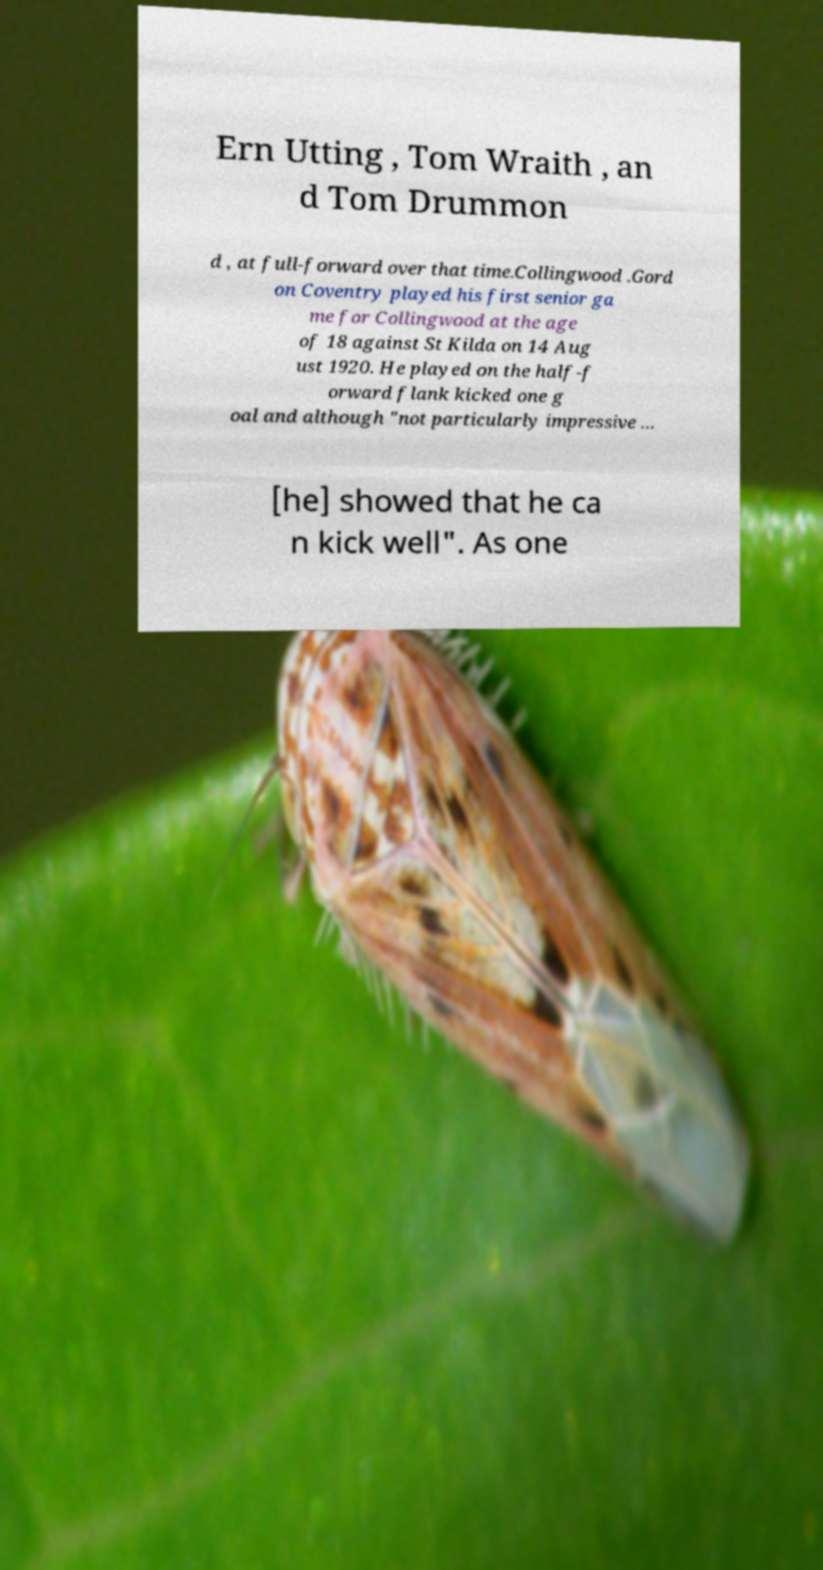Please read and relay the text visible in this image. What does it say? Ern Utting , Tom Wraith , an d Tom Drummon d , at full-forward over that time.Collingwood .Gord on Coventry played his first senior ga me for Collingwood at the age of 18 against St Kilda on 14 Aug ust 1920. He played on the half-f orward flank kicked one g oal and although "not particularly impressive … [he] showed that he ca n kick well". As one 